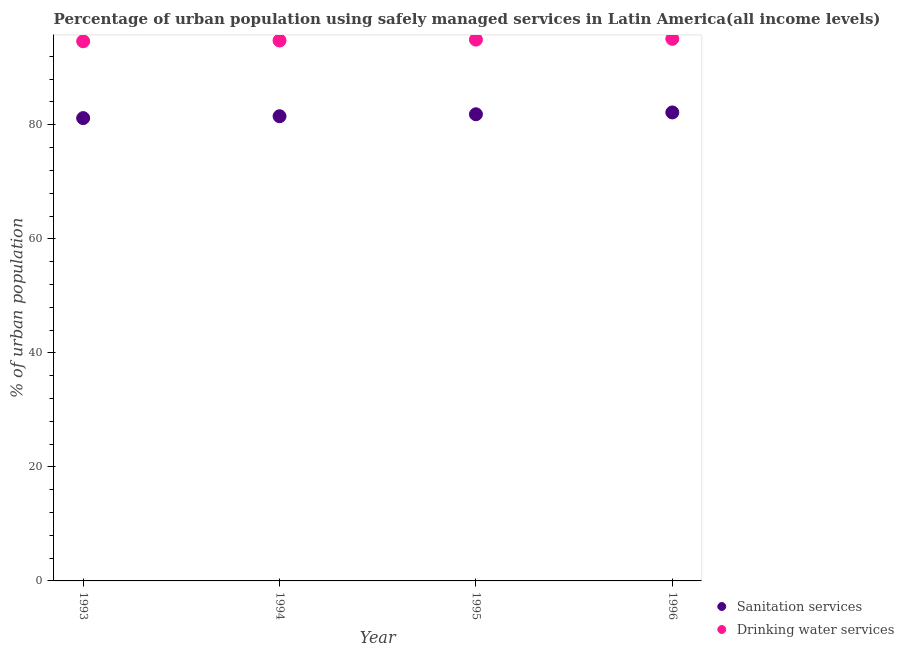Is the number of dotlines equal to the number of legend labels?
Make the answer very short. Yes. What is the percentage of urban population who used drinking water services in 1993?
Ensure brevity in your answer.  94.64. Across all years, what is the maximum percentage of urban population who used drinking water services?
Your answer should be very brief. 95.07. Across all years, what is the minimum percentage of urban population who used drinking water services?
Your answer should be very brief. 94.64. In which year was the percentage of urban population who used drinking water services minimum?
Your answer should be very brief. 1993. What is the total percentage of urban population who used drinking water services in the graph?
Ensure brevity in your answer.  379.42. What is the difference between the percentage of urban population who used drinking water services in 1993 and that in 1996?
Your answer should be very brief. -0.43. What is the difference between the percentage of urban population who used drinking water services in 1993 and the percentage of urban population who used sanitation services in 1995?
Your answer should be very brief. 12.8. What is the average percentage of urban population who used sanitation services per year?
Make the answer very short. 81.67. In the year 1993, what is the difference between the percentage of urban population who used drinking water services and percentage of urban population who used sanitation services?
Your answer should be compact. 13.48. What is the ratio of the percentage of urban population who used drinking water services in 1995 to that in 1996?
Ensure brevity in your answer.  1. Is the difference between the percentage of urban population who used sanitation services in 1995 and 1996 greater than the difference between the percentage of urban population who used drinking water services in 1995 and 1996?
Give a very brief answer. No. What is the difference between the highest and the second highest percentage of urban population who used sanitation services?
Offer a very short reply. 0.32. What is the difference between the highest and the lowest percentage of urban population who used drinking water services?
Offer a very short reply. 0.43. Is the percentage of urban population who used sanitation services strictly greater than the percentage of urban population who used drinking water services over the years?
Give a very brief answer. No. Is the percentage of urban population who used drinking water services strictly less than the percentage of urban population who used sanitation services over the years?
Your answer should be compact. No. How many years are there in the graph?
Offer a very short reply. 4. What is the difference between two consecutive major ticks on the Y-axis?
Provide a short and direct response. 20. Does the graph contain any zero values?
Ensure brevity in your answer.  No. Where does the legend appear in the graph?
Provide a succinct answer. Bottom right. How many legend labels are there?
Your answer should be compact. 2. How are the legend labels stacked?
Keep it short and to the point. Vertical. What is the title of the graph?
Offer a terse response. Percentage of urban population using safely managed services in Latin America(all income levels). What is the label or title of the X-axis?
Make the answer very short. Year. What is the label or title of the Y-axis?
Offer a very short reply. % of urban population. What is the % of urban population in Sanitation services in 1993?
Offer a very short reply. 81.17. What is the % of urban population in Drinking water services in 1993?
Your answer should be very brief. 94.64. What is the % of urban population in Sanitation services in 1994?
Your response must be concise. 81.5. What is the % of urban population in Drinking water services in 1994?
Keep it short and to the point. 94.78. What is the % of urban population in Sanitation services in 1995?
Ensure brevity in your answer.  81.84. What is the % of urban population of Drinking water services in 1995?
Make the answer very short. 94.93. What is the % of urban population in Sanitation services in 1996?
Keep it short and to the point. 82.16. What is the % of urban population in Drinking water services in 1996?
Make the answer very short. 95.07. Across all years, what is the maximum % of urban population in Sanitation services?
Make the answer very short. 82.16. Across all years, what is the maximum % of urban population in Drinking water services?
Keep it short and to the point. 95.07. Across all years, what is the minimum % of urban population of Sanitation services?
Offer a very short reply. 81.17. Across all years, what is the minimum % of urban population of Drinking water services?
Offer a very short reply. 94.64. What is the total % of urban population of Sanitation services in the graph?
Offer a terse response. 326.67. What is the total % of urban population in Drinking water services in the graph?
Offer a terse response. 379.42. What is the difference between the % of urban population in Sanitation services in 1993 and that in 1994?
Make the answer very short. -0.33. What is the difference between the % of urban population in Drinking water services in 1993 and that in 1994?
Offer a terse response. -0.13. What is the difference between the % of urban population in Sanitation services in 1993 and that in 1995?
Your response must be concise. -0.67. What is the difference between the % of urban population in Drinking water services in 1993 and that in 1995?
Offer a terse response. -0.29. What is the difference between the % of urban population of Sanitation services in 1993 and that in 1996?
Ensure brevity in your answer.  -1. What is the difference between the % of urban population of Drinking water services in 1993 and that in 1996?
Make the answer very short. -0.43. What is the difference between the % of urban population in Sanitation services in 1994 and that in 1995?
Provide a short and direct response. -0.34. What is the difference between the % of urban population in Drinking water services in 1994 and that in 1995?
Your answer should be very brief. -0.16. What is the difference between the % of urban population of Sanitation services in 1994 and that in 1996?
Your answer should be very brief. -0.67. What is the difference between the % of urban population in Drinking water services in 1994 and that in 1996?
Your answer should be compact. -0.3. What is the difference between the % of urban population of Sanitation services in 1995 and that in 1996?
Offer a very short reply. -0.32. What is the difference between the % of urban population of Drinking water services in 1995 and that in 1996?
Ensure brevity in your answer.  -0.14. What is the difference between the % of urban population of Sanitation services in 1993 and the % of urban population of Drinking water services in 1994?
Give a very brief answer. -13.61. What is the difference between the % of urban population in Sanitation services in 1993 and the % of urban population in Drinking water services in 1995?
Provide a succinct answer. -13.76. What is the difference between the % of urban population in Sanitation services in 1993 and the % of urban population in Drinking water services in 1996?
Ensure brevity in your answer.  -13.9. What is the difference between the % of urban population of Sanitation services in 1994 and the % of urban population of Drinking water services in 1995?
Offer a very short reply. -13.43. What is the difference between the % of urban population of Sanitation services in 1994 and the % of urban population of Drinking water services in 1996?
Give a very brief answer. -13.57. What is the difference between the % of urban population of Sanitation services in 1995 and the % of urban population of Drinking water services in 1996?
Keep it short and to the point. -13.23. What is the average % of urban population of Sanitation services per year?
Give a very brief answer. 81.67. What is the average % of urban population of Drinking water services per year?
Your answer should be compact. 94.86. In the year 1993, what is the difference between the % of urban population in Sanitation services and % of urban population in Drinking water services?
Your answer should be compact. -13.48. In the year 1994, what is the difference between the % of urban population in Sanitation services and % of urban population in Drinking water services?
Offer a terse response. -13.28. In the year 1995, what is the difference between the % of urban population of Sanitation services and % of urban population of Drinking water services?
Provide a succinct answer. -13.09. In the year 1996, what is the difference between the % of urban population of Sanitation services and % of urban population of Drinking water services?
Provide a succinct answer. -12.91. What is the ratio of the % of urban population in Sanitation services in 1993 to that in 1994?
Make the answer very short. 1. What is the ratio of the % of urban population in Drinking water services in 1993 to that in 1994?
Keep it short and to the point. 1. What is the ratio of the % of urban population in Sanitation services in 1993 to that in 1995?
Your response must be concise. 0.99. What is the ratio of the % of urban population of Sanitation services in 1993 to that in 1996?
Offer a very short reply. 0.99. What is the ratio of the % of urban population of Sanitation services in 1994 to that in 1996?
Give a very brief answer. 0.99. What is the ratio of the % of urban population of Drinking water services in 1995 to that in 1996?
Offer a very short reply. 1. What is the difference between the highest and the second highest % of urban population of Sanitation services?
Give a very brief answer. 0.32. What is the difference between the highest and the second highest % of urban population of Drinking water services?
Your answer should be compact. 0.14. What is the difference between the highest and the lowest % of urban population in Sanitation services?
Your answer should be very brief. 1. What is the difference between the highest and the lowest % of urban population in Drinking water services?
Keep it short and to the point. 0.43. 